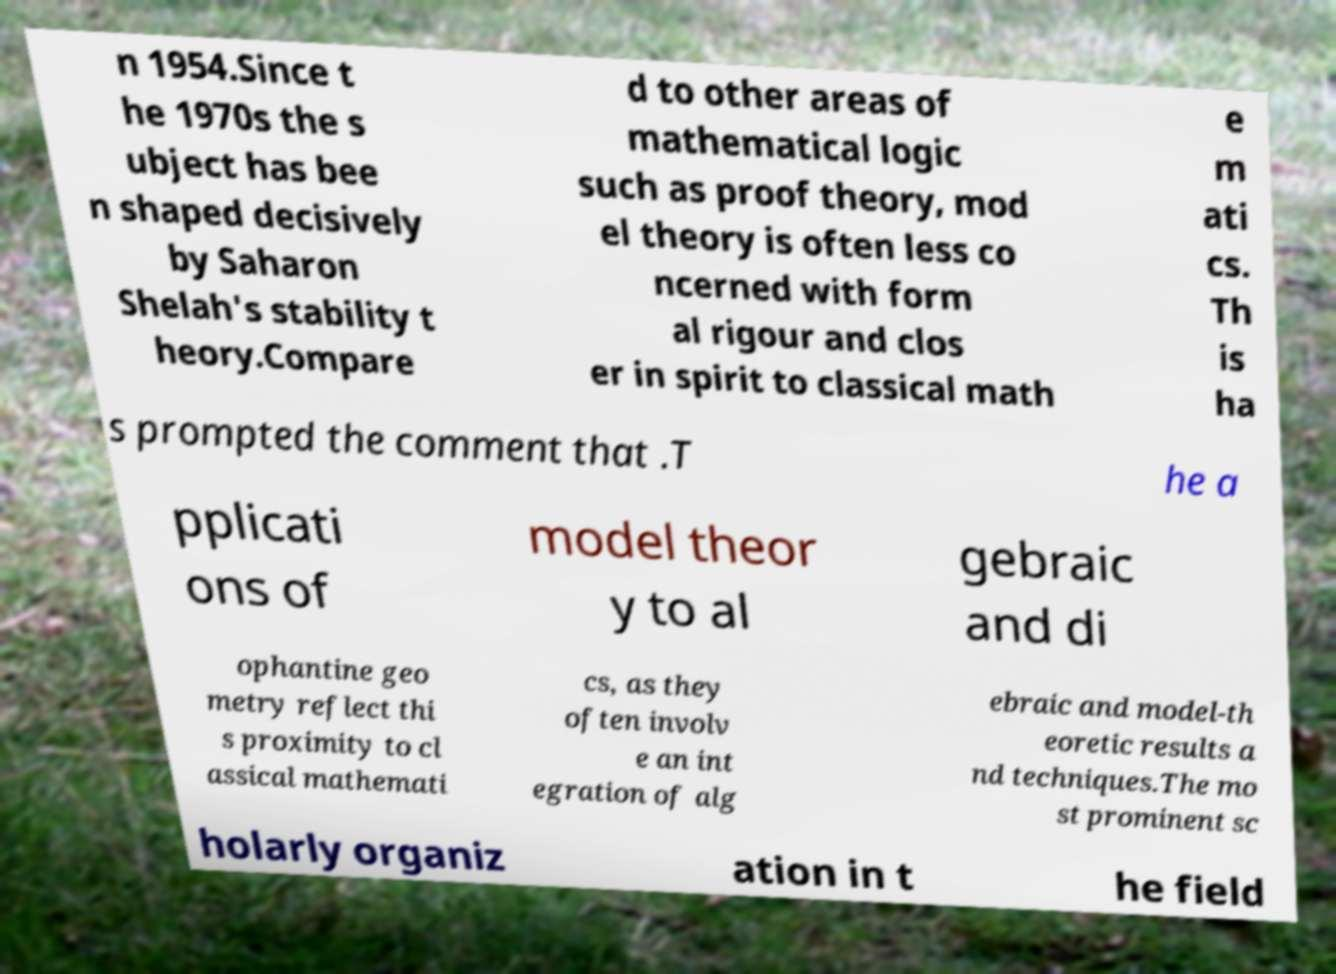For documentation purposes, I need the text within this image transcribed. Could you provide that? n 1954.Since t he 1970s the s ubject has bee n shaped decisively by Saharon Shelah's stability t heory.Compare d to other areas of mathematical logic such as proof theory, mod el theory is often less co ncerned with form al rigour and clos er in spirit to classical math e m ati cs. Th is ha s prompted the comment that .T he a pplicati ons of model theor y to al gebraic and di ophantine geo metry reflect thi s proximity to cl assical mathemati cs, as they often involv e an int egration of alg ebraic and model-th eoretic results a nd techniques.The mo st prominent sc holarly organiz ation in t he field 